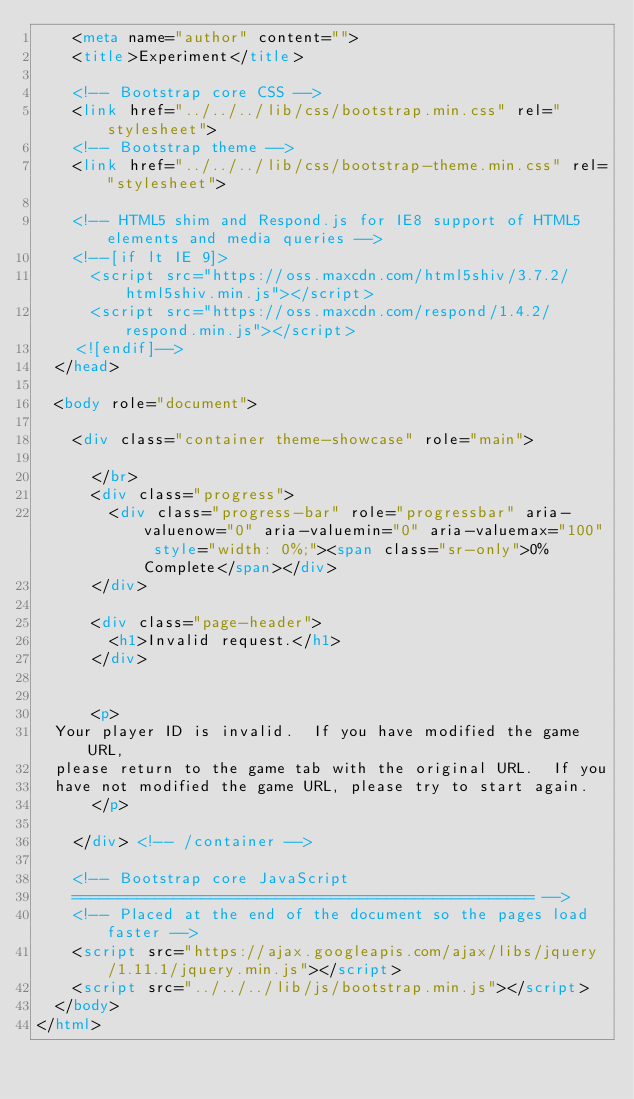<code> <loc_0><loc_0><loc_500><loc_500><_HTML_>    <meta name="author" content="">
    <title>Experiment</title>

    <!-- Bootstrap core CSS -->
    <link href="../../../lib/css/bootstrap.min.css" rel="stylesheet">
    <!-- Bootstrap theme -->
    <link href="../../../lib/css/bootstrap-theme.min.css" rel="stylesheet">

    <!-- HTML5 shim and Respond.js for IE8 support of HTML5 elements and media queries -->
    <!--[if lt IE 9]>
      <script src="https://oss.maxcdn.com/html5shiv/3.7.2/html5shiv.min.js"></script>
      <script src="https://oss.maxcdn.com/respond/1.4.2/respond.min.js"></script>
    <![endif]-->
  </head>

  <body role="document">

    <div class="container theme-showcase" role="main">

      </br>
      <div class="progress">
        <div class="progress-bar" role="progressbar" aria-valuenow="0" aria-valuemin="0" aria-valuemax="100" style="width: 0%;"><span class="sr-only">0% Complete</span></div>
      </div>

      <div class="page-header">
        <h1>Invalid request.</h1>
      </div>


      <p>
	Your player ID is invalid.  If you have modified the game URL,
	please return to the game tab with the original URL.  If you
	have not modified the game URL, please try to start again.
      </p>

    </div> <!-- /container -->

    <!-- Bootstrap core JavaScript
    ================================================== -->
    <!-- Placed at the end of the document so the pages load faster -->
    <script src="https://ajax.googleapis.com/ajax/libs/jquery/1.11.1/jquery.min.js"></script>
    <script src="../../../lib/js/bootstrap.min.js"></script>
  </body>
</html>
</code> 